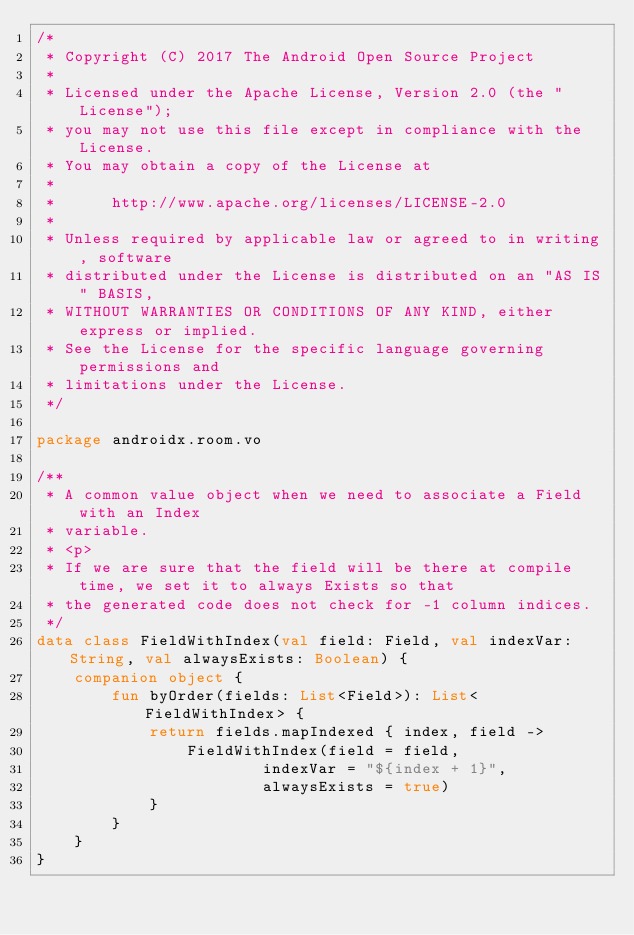<code> <loc_0><loc_0><loc_500><loc_500><_Kotlin_>/*
 * Copyright (C) 2017 The Android Open Source Project
 *
 * Licensed under the Apache License, Version 2.0 (the "License");
 * you may not use this file except in compliance with the License.
 * You may obtain a copy of the License at
 *
 *      http://www.apache.org/licenses/LICENSE-2.0
 *
 * Unless required by applicable law or agreed to in writing, software
 * distributed under the License is distributed on an "AS IS" BASIS,
 * WITHOUT WARRANTIES OR CONDITIONS OF ANY KIND, either express or implied.
 * See the License for the specific language governing permissions and
 * limitations under the License.
 */

package androidx.room.vo

/**
 * A common value object when we need to associate a Field with an Index
 * variable.
 * <p>
 * If we are sure that the field will be there at compile time, we set it to always Exists so that
 * the generated code does not check for -1 column indices.
 */
data class FieldWithIndex(val field: Field, val indexVar: String, val alwaysExists: Boolean) {
    companion object {
        fun byOrder(fields: List<Field>): List<FieldWithIndex> {
            return fields.mapIndexed { index, field ->
                FieldWithIndex(field = field,
                        indexVar = "${index + 1}",
                        alwaysExists = true)
            }
        }
    }
}
</code> 